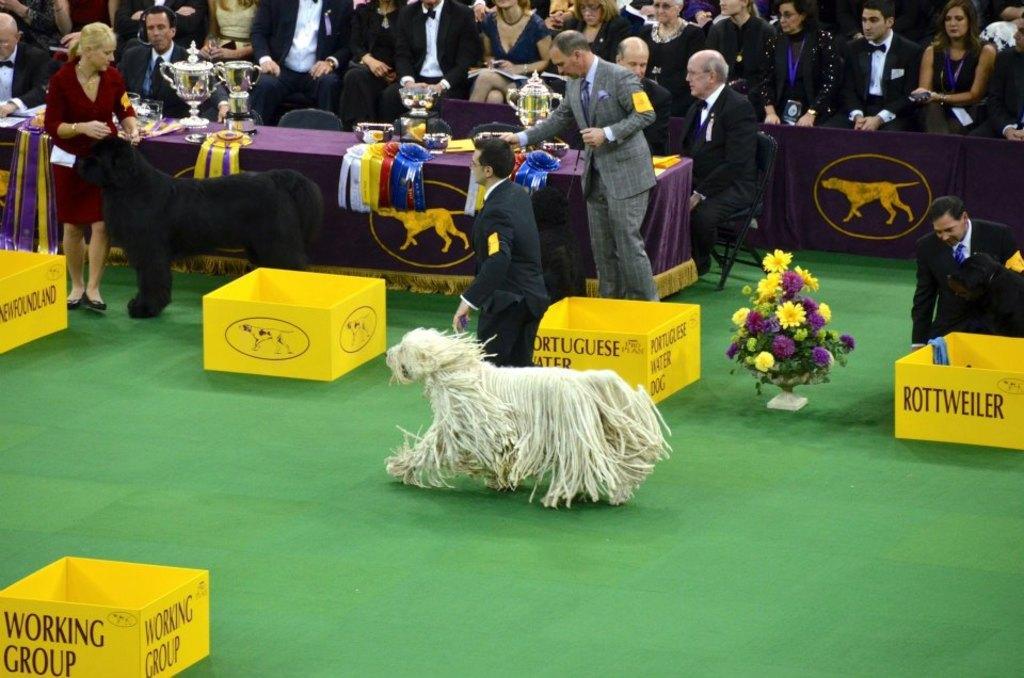Could you give a brief overview of what you see in this image? In this picture we can observe a dog which is in white color on the floor. The floor is in green color. On the left side there is another dog which is in black color. There are yellow color boxes. We can observe some people. There are men and women. We can observe some prizes placed on this table. 